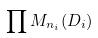<formula> <loc_0><loc_0><loc_500><loc_500>\prod M _ { n _ { i } } ( D _ { i } )</formula> 